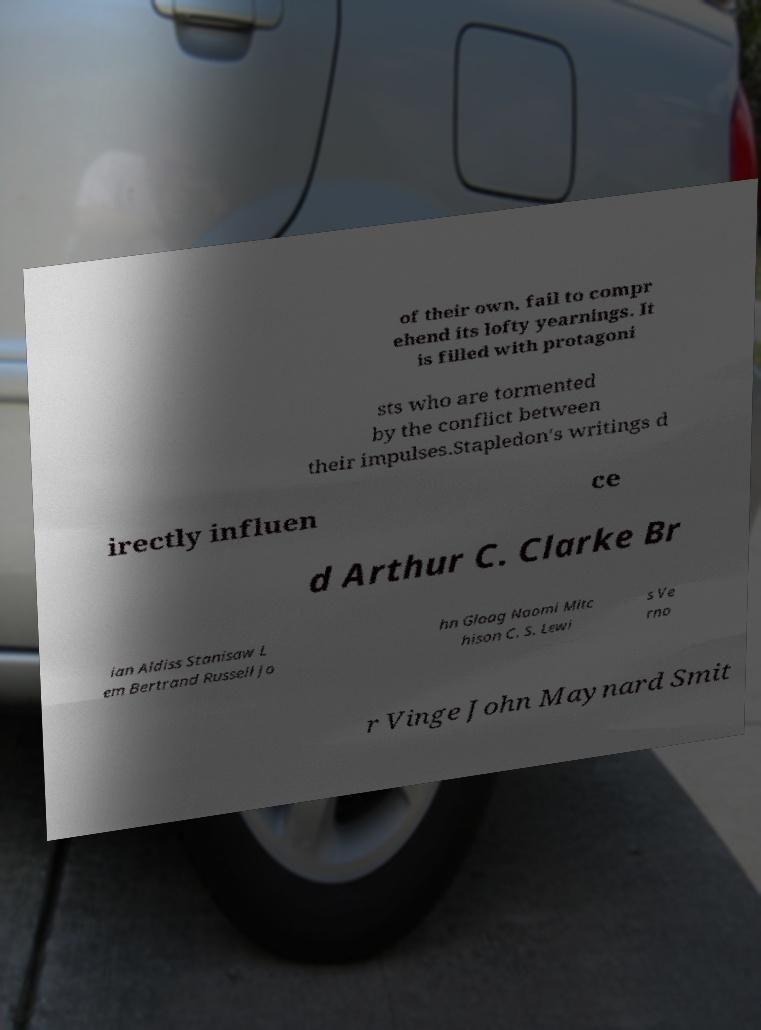Please identify and transcribe the text found in this image. of their own, fail to compr ehend its lofty yearnings. It is filled with protagoni sts who are tormented by the conflict between their impulses.Stapledon's writings d irectly influen ce d Arthur C. Clarke Br ian Aldiss Stanisaw L em Bertrand Russell Jo hn Gloag Naomi Mitc hison C. S. Lewi s Ve rno r Vinge John Maynard Smit 